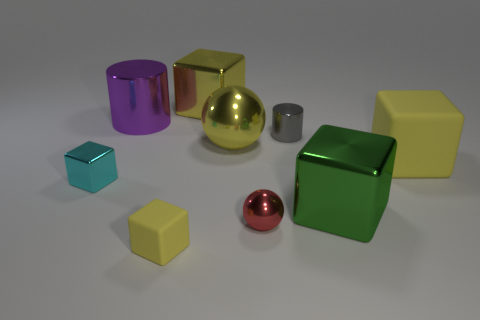How many yellow cubes must be subtracted to get 1 yellow cubes? 2 Subtract all large green metallic blocks. How many blocks are left? 4 Add 1 small things. How many objects exist? 10 Subtract 1 balls. How many balls are left? 1 Subtract all cyan spheres. How many yellow cubes are left? 3 Subtract all purple cylinders. How many cylinders are left? 1 Subtract 2 yellow blocks. How many objects are left? 7 Subtract all cylinders. How many objects are left? 7 Subtract all purple blocks. Subtract all blue spheres. How many blocks are left? 5 Subtract all big brown rubber cubes. Subtract all large yellow balls. How many objects are left? 8 